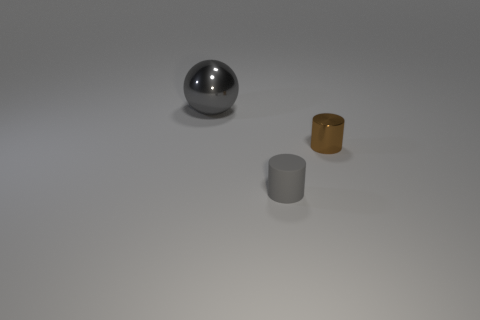Add 1 small yellow shiny cylinders. How many objects exist? 4 Subtract all cylinders. How many objects are left? 1 Subtract all gray shiny balls. Subtract all brown cylinders. How many objects are left? 1 Add 1 small gray cylinders. How many small gray cylinders are left? 2 Add 1 tiny gray objects. How many tiny gray objects exist? 2 Subtract 0 green cubes. How many objects are left? 3 